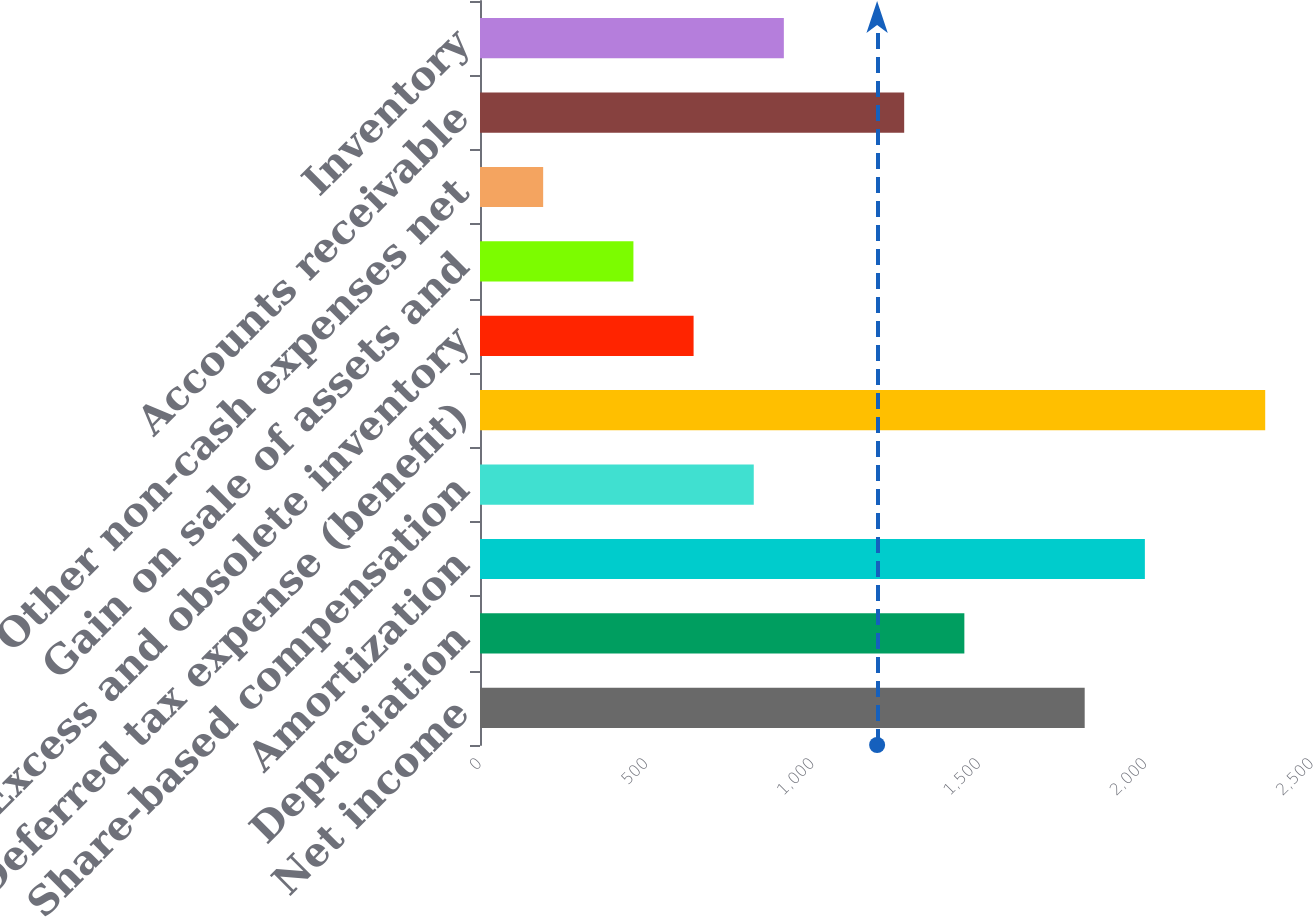<chart> <loc_0><loc_0><loc_500><loc_500><bar_chart><fcel>Net income<fcel>Depreciation<fcel>Amortization<fcel>Share-based compensation<fcel>Deferred tax expense (benefit)<fcel>Excess and obsolete inventory<fcel>Gain on sale of assets and<fcel>Other non-cash expenses net<fcel>Accounts receivable<fcel>Inventory<nl><fcel>1817<fcel>1455.4<fcel>1997.8<fcel>822.6<fcel>2359.4<fcel>641.8<fcel>461<fcel>189.8<fcel>1274.6<fcel>913<nl></chart> 